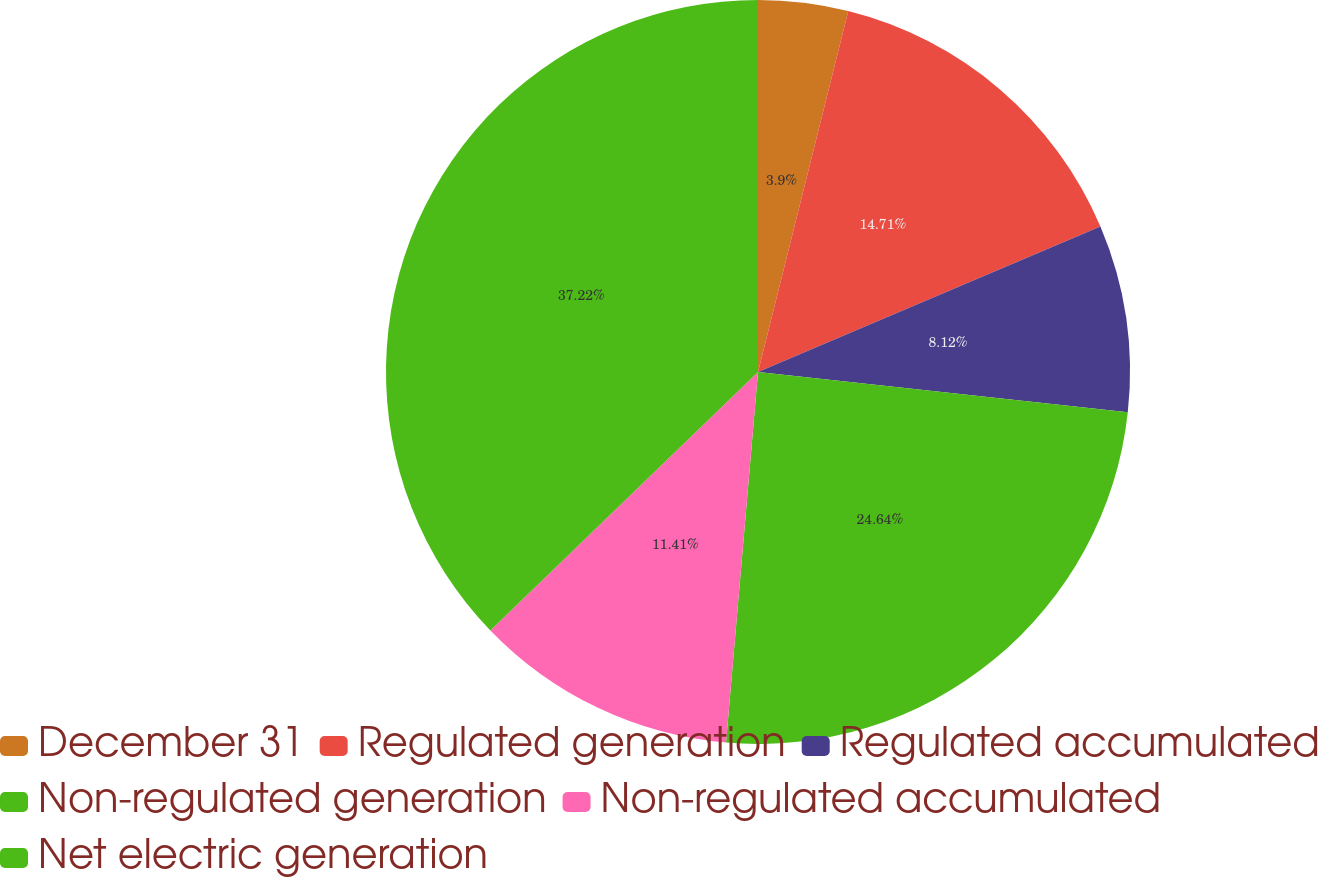<chart> <loc_0><loc_0><loc_500><loc_500><pie_chart><fcel>December 31<fcel>Regulated generation<fcel>Regulated accumulated<fcel>Non-regulated generation<fcel>Non-regulated accumulated<fcel>Net electric generation<nl><fcel>3.9%<fcel>14.71%<fcel>8.12%<fcel>24.64%<fcel>11.41%<fcel>37.22%<nl></chart> 